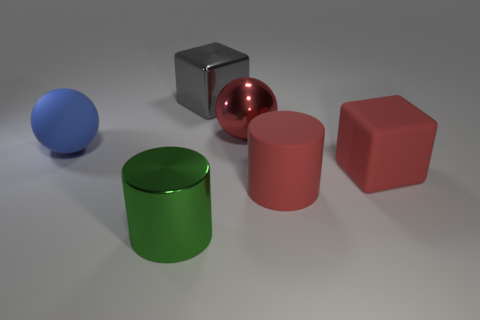Add 2 red spheres. How many objects exist? 8 Subtract all blue cubes. Subtract all green spheres. How many cubes are left? 2 Subtract all red balls. How many red cylinders are left? 1 Subtract all big objects. Subtract all tiny gray metallic objects. How many objects are left? 0 Add 5 big cylinders. How many big cylinders are left? 7 Add 2 blue rubber spheres. How many blue rubber spheres exist? 3 Subtract 0 blue blocks. How many objects are left? 6 Subtract all cubes. How many objects are left? 4 Subtract 1 balls. How many balls are left? 1 